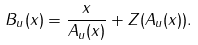Convert formula to latex. <formula><loc_0><loc_0><loc_500><loc_500>B _ { u } ( x ) = \frac { x } { A _ { u } ( x ) } + Z ( A _ { u } ( x ) ) .</formula> 